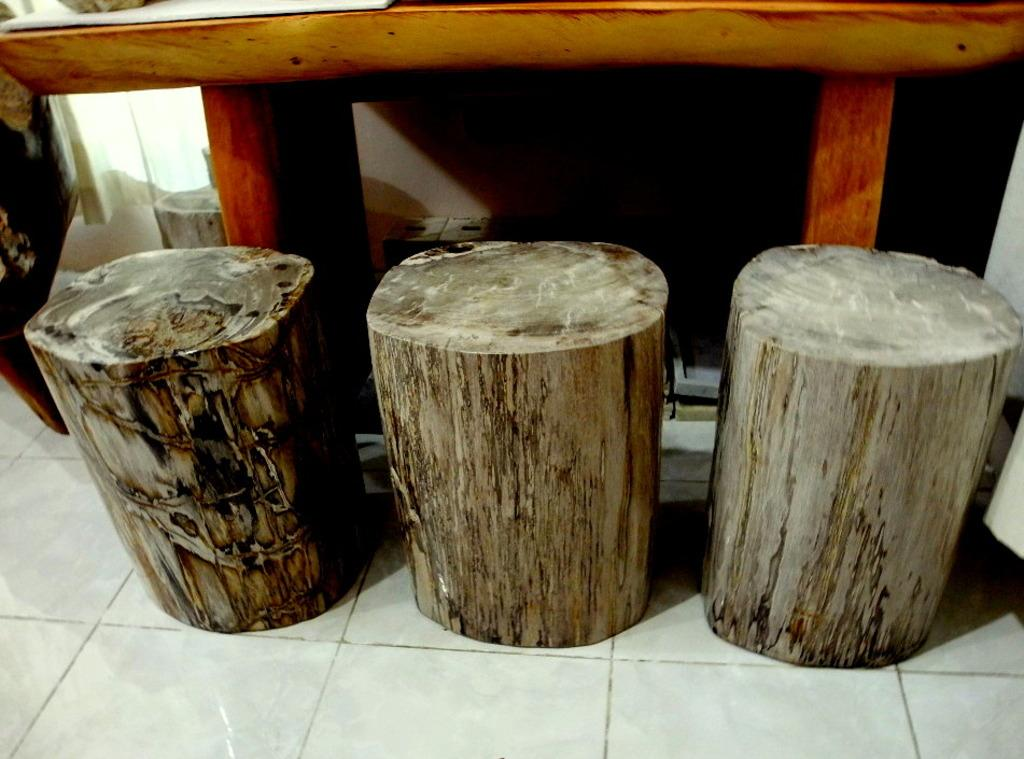What type of material is covering the floor in the image? There are wooden logs on the floor in the image. What color is the cloth visible in the image? There is a white cloth in the image. What is the background of the image made of? There is a wall in the image. Can you describe any objects present in the image? There are some objects in the image, but their specific details are not mentioned in the provided facts. How many mint leaves are on the white cloth in the image? There is no mention of mint leaves in the provided facts, so we cannot determine their presence or quantity in the image. What type of balls can be seen rolling on the wooden logs in the image? There are no balls present in the image; it only features wooden logs on the floor. 